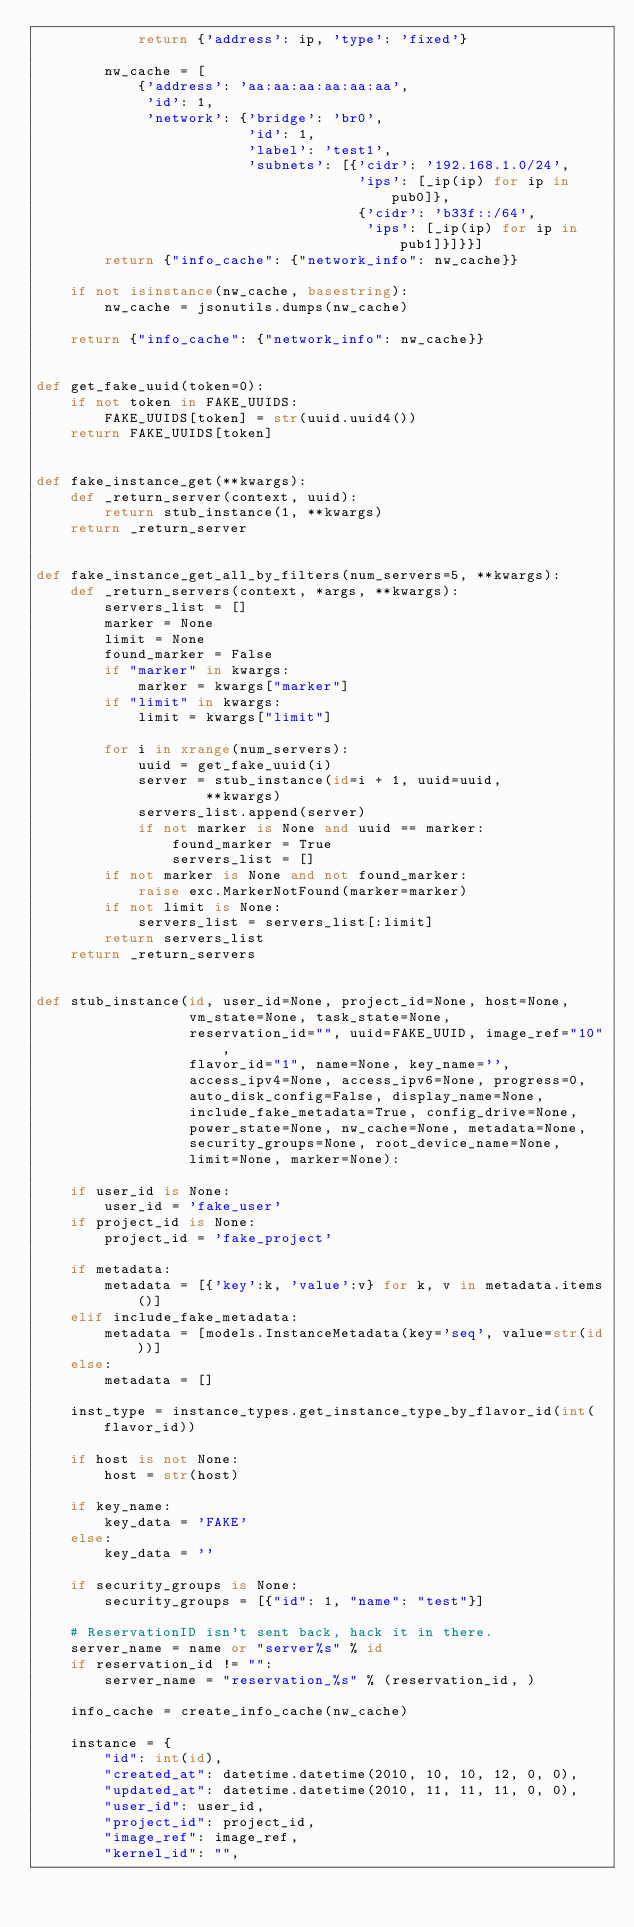Convert code to text. <code><loc_0><loc_0><loc_500><loc_500><_Python_>            return {'address': ip, 'type': 'fixed'}

        nw_cache = [
            {'address': 'aa:aa:aa:aa:aa:aa',
             'id': 1,
             'network': {'bridge': 'br0',
                         'id': 1,
                         'label': 'test1',
                         'subnets': [{'cidr': '192.168.1.0/24',
                                      'ips': [_ip(ip) for ip in pub0]},
                                      {'cidr': 'b33f::/64',
                                       'ips': [_ip(ip) for ip in pub1]}]}}]
        return {"info_cache": {"network_info": nw_cache}}

    if not isinstance(nw_cache, basestring):
        nw_cache = jsonutils.dumps(nw_cache)

    return {"info_cache": {"network_info": nw_cache}}


def get_fake_uuid(token=0):
    if not token in FAKE_UUIDS:
        FAKE_UUIDS[token] = str(uuid.uuid4())
    return FAKE_UUIDS[token]


def fake_instance_get(**kwargs):
    def _return_server(context, uuid):
        return stub_instance(1, **kwargs)
    return _return_server


def fake_instance_get_all_by_filters(num_servers=5, **kwargs):
    def _return_servers(context, *args, **kwargs):
        servers_list = []
        marker = None
        limit = None
        found_marker = False
        if "marker" in kwargs:
            marker = kwargs["marker"]
        if "limit" in kwargs:
            limit = kwargs["limit"]

        for i in xrange(num_servers):
            uuid = get_fake_uuid(i)
            server = stub_instance(id=i + 1, uuid=uuid,
                    **kwargs)
            servers_list.append(server)
            if not marker is None and uuid == marker:
                found_marker = True
                servers_list = []
        if not marker is None and not found_marker:
            raise exc.MarkerNotFound(marker=marker)
        if not limit is None:
            servers_list = servers_list[:limit]
        return servers_list
    return _return_servers


def stub_instance(id, user_id=None, project_id=None, host=None,
                  vm_state=None, task_state=None,
                  reservation_id="", uuid=FAKE_UUID, image_ref="10",
                  flavor_id="1", name=None, key_name='',
                  access_ipv4=None, access_ipv6=None, progress=0,
                  auto_disk_config=False, display_name=None,
                  include_fake_metadata=True, config_drive=None,
                  power_state=None, nw_cache=None, metadata=None,
                  security_groups=None, root_device_name=None,
                  limit=None, marker=None):

    if user_id is None:
        user_id = 'fake_user'
    if project_id is None:
        project_id = 'fake_project'

    if metadata:
        metadata = [{'key':k, 'value':v} for k, v in metadata.items()]
    elif include_fake_metadata:
        metadata = [models.InstanceMetadata(key='seq', value=str(id))]
    else:
        metadata = []

    inst_type = instance_types.get_instance_type_by_flavor_id(int(flavor_id))

    if host is not None:
        host = str(host)

    if key_name:
        key_data = 'FAKE'
    else:
        key_data = ''

    if security_groups is None:
        security_groups = [{"id": 1, "name": "test"}]

    # ReservationID isn't sent back, hack it in there.
    server_name = name or "server%s" % id
    if reservation_id != "":
        server_name = "reservation_%s" % (reservation_id, )

    info_cache = create_info_cache(nw_cache)

    instance = {
        "id": int(id),
        "created_at": datetime.datetime(2010, 10, 10, 12, 0, 0),
        "updated_at": datetime.datetime(2010, 11, 11, 11, 0, 0),
        "user_id": user_id,
        "project_id": project_id,
        "image_ref": image_ref,
        "kernel_id": "",</code> 